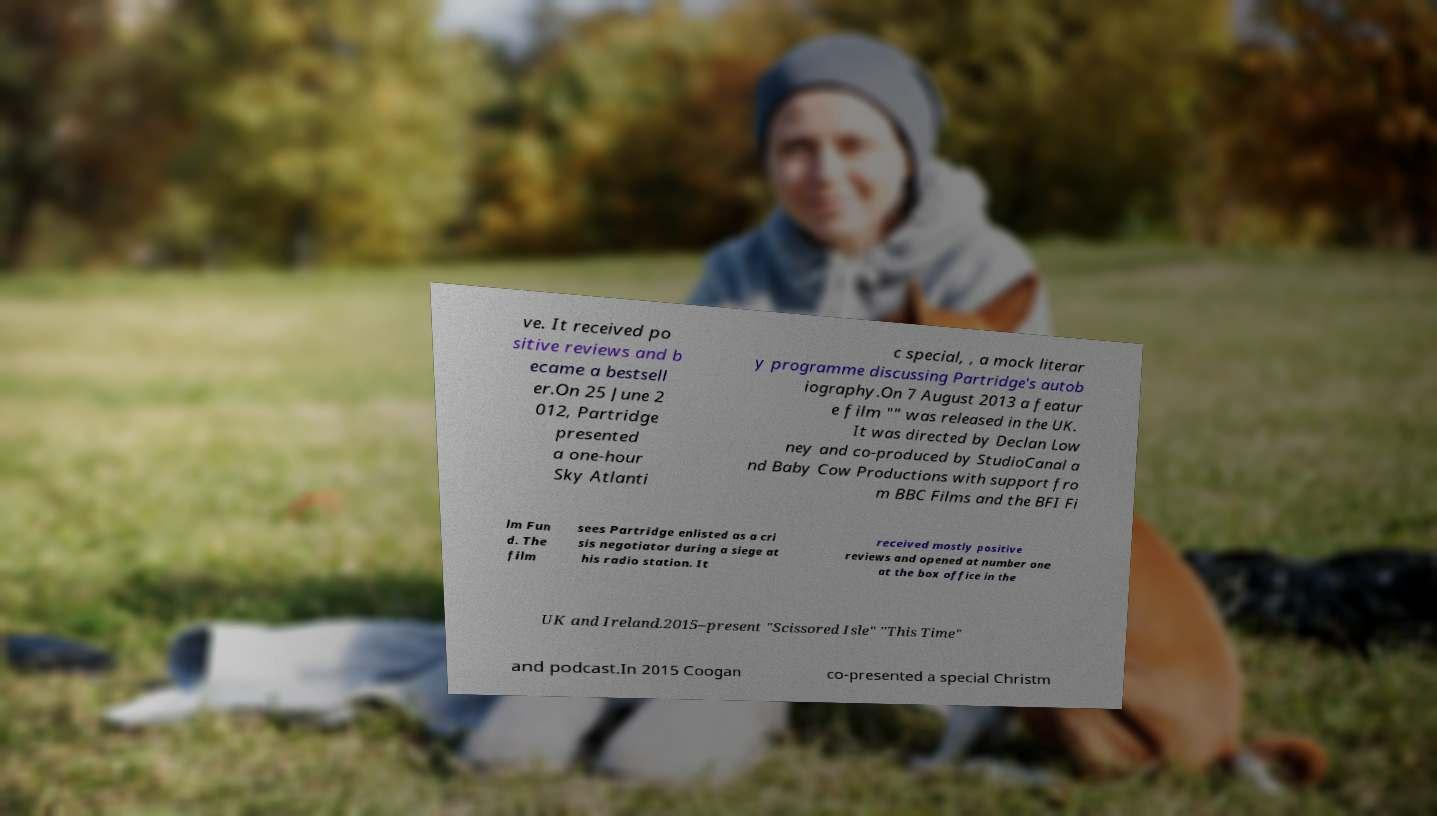What messages or text are displayed in this image? I need them in a readable, typed format. ve. It received po sitive reviews and b ecame a bestsell er.On 25 June 2 012, Partridge presented a one-hour Sky Atlanti c special, , a mock literar y programme discussing Partridge's autob iography.On 7 August 2013 a featur e film "" was released in the UK. It was directed by Declan Low ney and co-produced by StudioCanal a nd Baby Cow Productions with support fro m BBC Films and the BFI Fi lm Fun d. The film sees Partridge enlisted as a cri sis negotiator during a siege at his radio station. It received mostly positive reviews and opened at number one at the box office in the UK and Ireland.2015–present "Scissored Isle" "This Time" and podcast.In 2015 Coogan co-presented a special Christm 